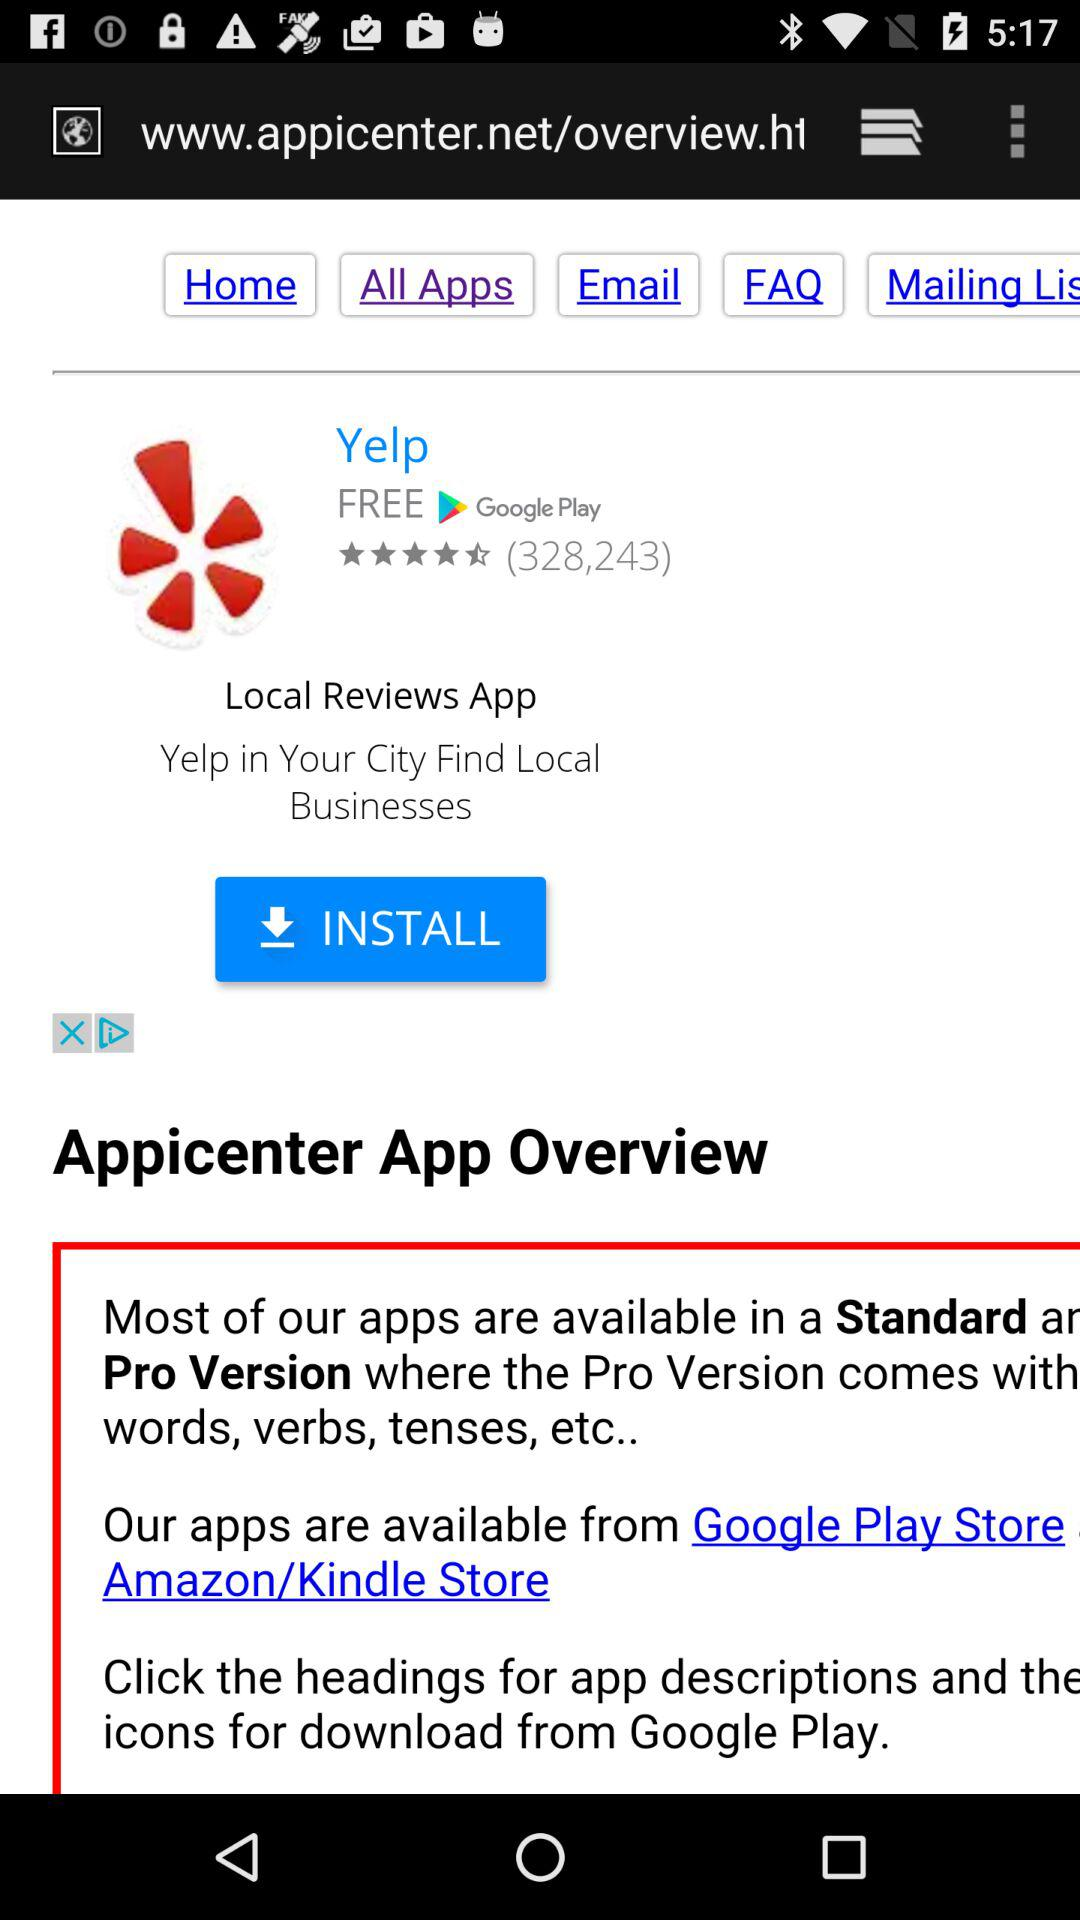Which tab is selected? The selected tab is "All Apps". 